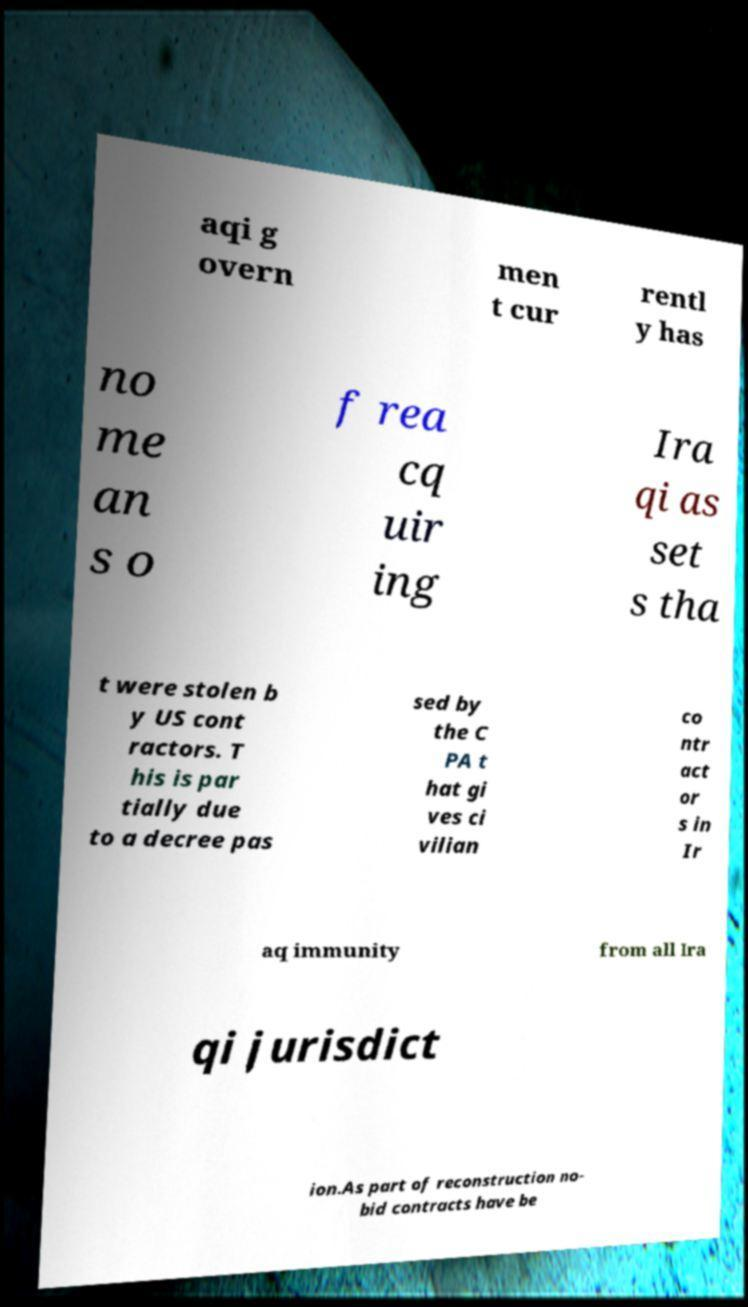Could you assist in decoding the text presented in this image and type it out clearly? aqi g overn men t cur rentl y has no me an s o f rea cq uir ing Ira qi as set s tha t were stolen b y US cont ractors. T his is par tially due to a decree pas sed by the C PA t hat gi ves ci vilian co ntr act or s in Ir aq immunity from all Ira qi jurisdict ion.As part of reconstruction no- bid contracts have be 